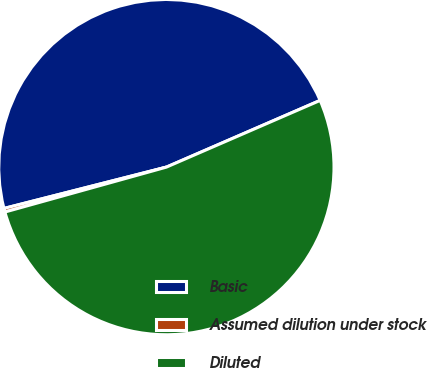Convert chart to OTSL. <chart><loc_0><loc_0><loc_500><loc_500><pie_chart><fcel>Basic<fcel>Assumed dilution under stock<fcel>Diluted<nl><fcel>47.45%<fcel>0.35%<fcel>52.2%<nl></chart> 